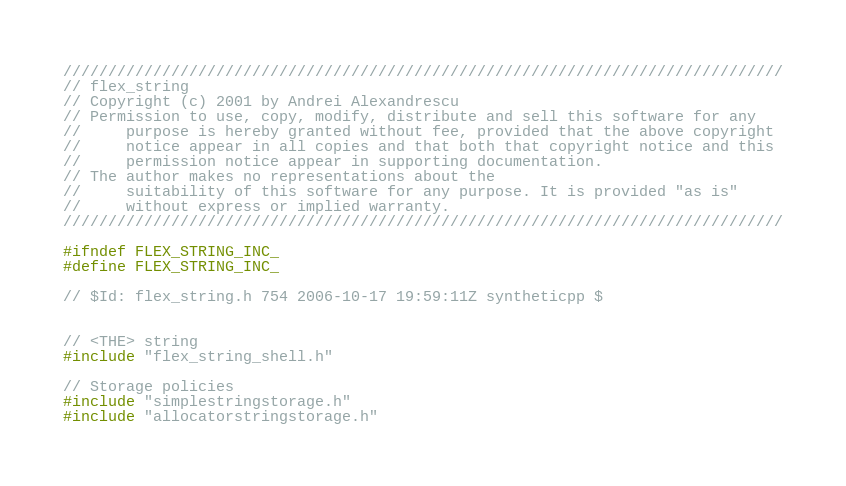Convert code to text. <code><loc_0><loc_0><loc_500><loc_500><_C_>////////////////////////////////////////////////////////////////////////////////
// flex_string
// Copyright (c) 2001 by Andrei Alexandrescu
// Permission to use, copy, modify, distribute and sell this software for any
//     purpose is hereby granted without fee, provided that the above copyright
//     notice appear in all copies and that both that copyright notice and this
//     permission notice appear in supporting documentation.
// The author makes no representations about the
//     suitability of this software for any purpose. It is provided "as is"
//     without express or implied warranty.
////////////////////////////////////////////////////////////////////////////////

#ifndef FLEX_STRING_INC_
#define FLEX_STRING_INC_

// $Id: flex_string.h 754 2006-10-17 19:59:11Z syntheticpp $


// <THE> string
#include "flex_string_shell.h"

// Storage policies
#include "simplestringstorage.h"
#include "allocatorstringstorage.h"</code> 